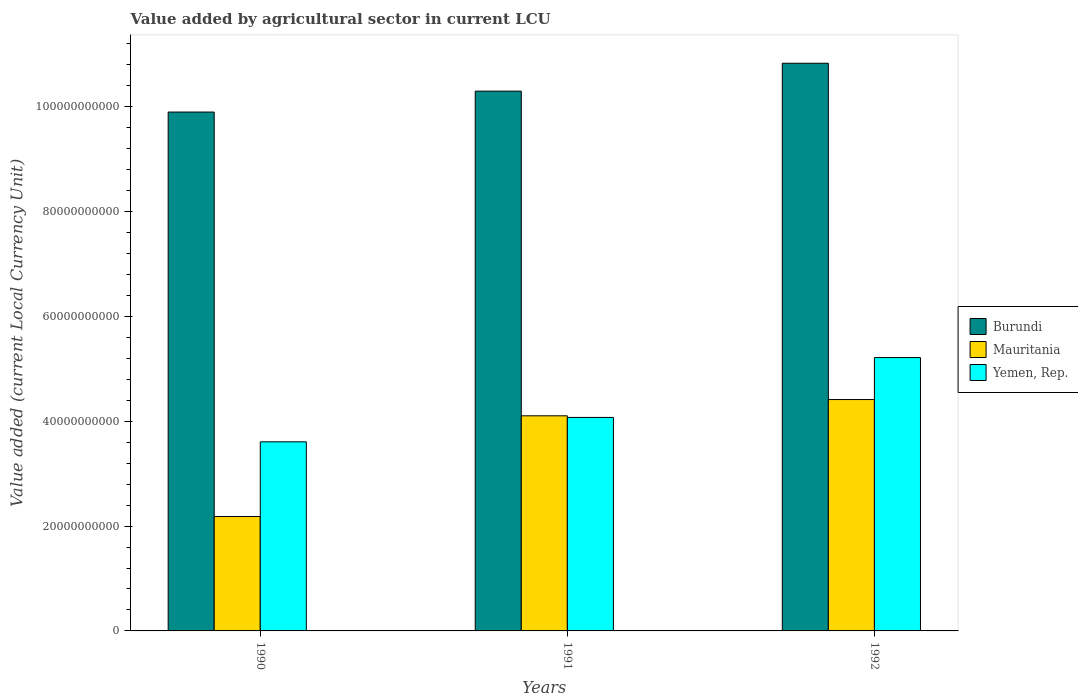How many different coloured bars are there?
Keep it short and to the point. 3. Are the number of bars per tick equal to the number of legend labels?
Provide a succinct answer. Yes. What is the label of the 1st group of bars from the left?
Ensure brevity in your answer.  1990. In how many cases, is the number of bars for a given year not equal to the number of legend labels?
Offer a terse response. 0. What is the value added by agricultural sector in Mauritania in 1991?
Offer a very short reply. 4.10e+1. Across all years, what is the maximum value added by agricultural sector in Mauritania?
Make the answer very short. 4.41e+1. Across all years, what is the minimum value added by agricultural sector in Mauritania?
Make the answer very short. 2.18e+1. In which year was the value added by agricultural sector in Mauritania maximum?
Ensure brevity in your answer.  1992. What is the total value added by agricultural sector in Yemen, Rep. in the graph?
Keep it short and to the point. 1.29e+11. What is the difference between the value added by agricultural sector in Mauritania in 1990 and that in 1992?
Your answer should be compact. -2.23e+1. What is the difference between the value added by agricultural sector in Yemen, Rep. in 1992 and the value added by agricultural sector in Burundi in 1991?
Your response must be concise. -5.08e+1. What is the average value added by agricultural sector in Yemen, Rep. per year?
Provide a short and direct response. 4.30e+1. In the year 1991, what is the difference between the value added by agricultural sector in Mauritania and value added by agricultural sector in Yemen, Rep.?
Your answer should be compact. 3.12e+08. What is the ratio of the value added by agricultural sector in Yemen, Rep. in 1991 to that in 1992?
Provide a short and direct response. 0.78. Is the value added by agricultural sector in Yemen, Rep. in 1990 less than that in 1992?
Offer a very short reply. Yes. Is the difference between the value added by agricultural sector in Mauritania in 1991 and 1992 greater than the difference between the value added by agricultural sector in Yemen, Rep. in 1991 and 1992?
Ensure brevity in your answer.  Yes. What is the difference between the highest and the second highest value added by agricultural sector in Mauritania?
Provide a short and direct response. 3.10e+09. What is the difference between the highest and the lowest value added by agricultural sector in Mauritania?
Keep it short and to the point. 2.23e+1. Is the sum of the value added by agricultural sector in Yemen, Rep. in 1990 and 1991 greater than the maximum value added by agricultural sector in Mauritania across all years?
Offer a terse response. Yes. What does the 1st bar from the left in 1992 represents?
Your response must be concise. Burundi. What does the 1st bar from the right in 1992 represents?
Make the answer very short. Yemen, Rep. Are all the bars in the graph horizontal?
Offer a terse response. No. Does the graph contain any zero values?
Ensure brevity in your answer.  No. How are the legend labels stacked?
Your response must be concise. Vertical. What is the title of the graph?
Offer a very short reply. Value added by agricultural sector in current LCU. Does "Hungary" appear as one of the legend labels in the graph?
Your answer should be compact. No. What is the label or title of the Y-axis?
Offer a very short reply. Value added (current Local Currency Unit). What is the Value added (current Local Currency Unit) of Burundi in 1990?
Provide a succinct answer. 9.90e+1. What is the Value added (current Local Currency Unit) of Mauritania in 1990?
Give a very brief answer. 2.18e+1. What is the Value added (current Local Currency Unit) in Yemen, Rep. in 1990?
Offer a terse response. 3.61e+1. What is the Value added (current Local Currency Unit) in Burundi in 1991?
Your answer should be very brief. 1.03e+11. What is the Value added (current Local Currency Unit) in Mauritania in 1991?
Keep it short and to the point. 4.10e+1. What is the Value added (current Local Currency Unit) of Yemen, Rep. in 1991?
Make the answer very short. 4.07e+1. What is the Value added (current Local Currency Unit) of Burundi in 1992?
Make the answer very short. 1.08e+11. What is the Value added (current Local Currency Unit) of Mauritania in 1992?
Offer a terse response. 4.41e+1. What is the Value added (current Local Currency Unit) of Yemen, Rep. in 1992?
Make the answer very short. 5.21e+1. Across all years, what is the maximum Value added (current Local Currency Unit) in Burundi?
Ensure brevity in your answer.  1.08e+11. Across all years, what is the maximum Value added (current Local Currency Unit) in Mauritania?
Your answer should be very brief. 4.41e+1. Across all years, what is the maximum Value added (current Local Currency Unit) in Yemen, Rep.?
Give a very brief answer. 5.21e+1. Across all years, what is the minimum Value added (current Local Currency Unit) in Burundi?
Your answer should be compact. 9.90e+1. Across all years, what is the minimum Value added (current Local Currency Unit) of Mauritania?
Offer a very short reply. 2.18e+1. Across all years, what is the minimum Value added (current Local Currency Unit) in Yemen, Rep.?
Keep it short and to the point. 3.61e+1. What is the total Value added (current Local Currency Unit) in Burundi in the graph?
Give a very brief answer. 3.10e+11. What is the total Value added (current Local Currency Unit) of Mauritania in the graph?
Make the answer very short. 1.07e+11. What is the total Value added (current Local Currency Unit) in Yemen, Rep. in the graph?
Keep it short and to the point. 1.29e+11. What is the difference between the Value added (current Local Currency Unit) of Burundi in 1990 and that in 1991?
Keep it short and to the point. -3.99e+09. What is the difference between the Value added (current Local Currency Unit) of Mauritania in 1990 and that in 1991?
Make the answer very short. -1.92e+1. What is the difference between the Value added (current Local Currency Unit) in Yemen, Rep. in 1990 and that in 1991?
Offer a very short reply. -4.66e+09. What is the difference between the Value added (current Local Currency Unit) of Burundi in 1990 and that in 1992?
Make the answer very short. -9.31e+09. What is the difference between the Value added (current Local Currency Unit) of Mauritania in 1990 and that in 1992?
Provide a short and direct response. -2.23e+1. What is the difference between the Value added (current Local Currency Unit) in Yemen, Rep. in 1990 and that in 1992?
Ensure brevity in your answer.  -1.61e+1. What is the difference between the Value added (current Local Currency Unit) of Burundi in 1991 and that in 1992?
Your answer should be compact. -5.32e+09. What is the difference between the Value added (current Local Currency Unit) in Mauritania in 1991 and that in 1992?
Your response must be concise. -3.10e+09. What is the difference between the Value added (current Local Currency Unit) in Yemen, Rep. in 1991 and that in 1992?
Offer a terse response. -1.14e+1. What is the difference between the Value added (current Local Currency Unit) in Burundi in 1990 and the Value added (current Local Currency Unit) in Mauritania in 1991?
Provide a succinct answer. 5.79e+1. What is the difference between the Value added (current Local Currency Unit) of Burundi in 1990 and the Value added (current Local Currency Unit) of Yemen, Rep. in 1991?
Make the answer very short. 5.83e+1. What is the difference between the Value added (current Local Currency Unit) in Mauritania in 1990 and the Value added (current Local Currency Unit) in Yemen, Rep. in 1991?
Make the answer very short. -1.89e+1. What is the difference between the Value added (current Local Currency Unit) of Burundi in 1990 and the Value added (current Local Currency Unit) of Mauritania in 1992?
Provide a succinct answer. 5.48e+1. What is the difference between the Value added (current Local Currency Unit) of Burundi in 1990 and the Value added (current Local Currency Unit) of Yemen, Rep. in 1992?
Keep it short and to the point. 4.68e+1. What is the difference between the Value added (current Local Currency Unit) of Mauritania in 1990 and the Value added (current Local Currency Unit) of Yemen, Rep. in 1992?
Provide a short and direct response. -3.03e+1. What is the difference between the Value added (current Local Currency Unit) in Burundi in 1991 and the Value added (current Local Currency Unit) in Mauritania in 1992?
Offer a very short reply. 5.88e+1. What is the difference between the Value added (current Local Currency Unit) of Burundi in 1991 and the Value added (current Local Currency Unit) of Yemen, Rep. in 1992?
Provide a succinct answer. 5.08e+1. What is the difference between the Value added (current Local Currency Unit) of Mauritania in 1991 and the Value added (current Local Currency Unit) of Yemen, Rep. in 1992?
Your answer should be very brief. -1.11e+1. What is the average Value added (current Local Currency Unit) of Burundi per year?
Your answer should be very brief. 1.03e+11. What is the average Value added (current Local Currency Unit) in Mauritania per year?
Give a very brief answer. 3.57e+1. What is the average Value added (current Local Currency Unit) in Yemen, Rep. per year?
Make the answer very short. 4.30e+1. In the year 1990, what is the difference between the Value added (current Local Currency Unit) of Burundi and Value added (current Local Currency Unit) of Mauritania?
Offer a terse response. 7.72e+1. In the year 1990, what is the difference between the Value added (current Local Currency Unit) in Burundi and Value added (current Local Currency Unit) in Yemen, Rep.?
Your response must be concise. 6.29e+1. In the year 1990, what is the difference between the Value added (current Local Currency Unit) of Mauritania and Value added (current Local Currency Unit) of Yemen, Rep.?
Your answer should be compact. -1.42e+1. In the year 1991, what is the difference between the Value added (current Local Currency Unit) in Burundi and Value added (current Local Currency Unit) in Mauritania?
Keep it short and to the point. 6.19e+1. In the year 1991, what is the difference between the Value added (current Local Currency Unit) of Burundi and Value added (current Local Currency Unit) of Yemen, Rep.?
Your answer should be compact. 6.22e+1. In the year 1991, what is the difference between the Value added (current Local Currency Unit) of Mauritania and Value added (current Local Currency Unit) of Yemen, Rep.?
Your response must be concise. 3.12e+08. In the year 1992, what is the difference between the Value added (current Local Currency Unit) in Burundi and Value added (current Local Currency Unit) in Mauritania?
Give a very brief answer. 6.42e+1. In the year 1992, what is the difference between the Value added (current Local Currency Unit) of Burundi and Value added (current Local Currency Unit) of Yemen, Rep.?
Your response must be concise. 5.61e+1. In the year 1992, what is the difference between the Value added (current Local Currency Unit) in Mauritania and Value added (current Local Currency Unit) in Yemen, Rep.?
Ensure brevity in your answer.  -8.01e+09. What is the ratio of the Value added (current Local Currency Unit) of Burundi in 1990 to that in 1991?
Your response must be concise. 0.96. What is the ratio of the Value added (current Local Currency Unit) in Mauritania in 1990 to that in 1991?
Your answer should be very brief. 0.53. What is the ratio of the Value added (current Local Currency Unit) of Yemen, Rep. in 1990 to that in 1991?
Your answer should be very brief. 0.89. What is the ratio of the Value added (current Local Currency Unit) in Burundi in 1990 to that in 1992?
Give a very brief answer. 0.91. What is the ratio of the Value added (current Local Currency Unit) of Mauritania in 1990 to that in 1992?
Your answer should be compact. 0.49. What is the ratio of the Value added (current Local Currency Unit) in Yemen, Rep. in 1990 to that in 1992?
Make the answer very short. 0.69. What is the ratio of the Value added (current Local Currency Unit) of Burundi in 1991 to that in 1992?
Ensure brevity in your answer.  0.95. What is the ratio of the Value added (current Local Currency Unit) of Mauritania in 1991 to that in 1992?
Your answer should be compact. 0.93. What is the ratio of the Value added (current Local Currency Unit) in Yemen, Rep. in 1991 to that in 1992?
Offer a very short reply. 0.78. What is the difference between the highest and the second highest Value added (current Local Currency Unit) in Burundi?
Ensure brevity in your answer.  5.32e+09. What is the difference between the highest and the second highest Value added (current Local Currency Unit) in Mauritania?
Offer a terse response. 3.10e+09. What is the difference between the highest and the second highest Value added (current Local Currency Unit) in Yemen, Rep.?
Keep it short and to the point. 1.14e+1. What is the difference between the highest and the lowest Value added (current Local Currency Unit) of Burundi?
Provide a short and direct response. 9.31e+09. What is the difference between the highest and the lowest Value added (current Local Currency Unit) in Mauritania?
Your answer should be compact. 2.23e+1. What is the difference between the highest and the lowest Value added (current Local Currency Unit) in Yemen, Rep.?
Provide a succinct answer. 1.61e+1. 